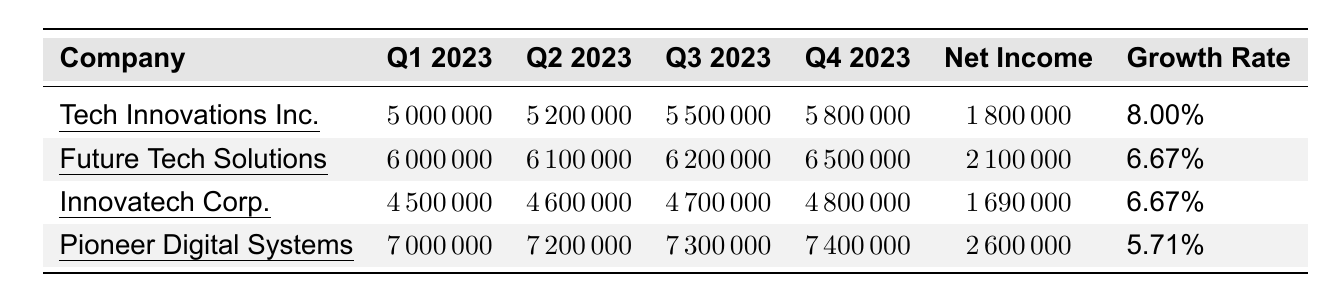What is the highest quarterly revenue reported in Q4 2023? From the table, the revenues for Q4 2023 are as follows: Tech Innovations Inc. is 5800000, Future Tech Solutions is 6500000, Innovatech Corp. is 4800000, and Pioneer Digital Systems is 7400000. The highest among these values is 7400000.
Answer: 7400000 Which company had the lowest net income? The net incomes listed are: Tech Innovations Inc. at 1800000, Future Tech Solutions at 2100000, Innovatech Corp. at 1690000, and Pioneer Digital Systems at 2600000. The lowest net income is from Innovatech Corp. at 1690000.
Answer: Innovatech Corp What is the average revenue for Q1 2023 across all companies? The revenues for Q1 2023 are: 5000000 (Tech Innovations Inc.), 6000000 (Future Tech Solutions), 4500000 (Innovatech Corp.), and 7000000 (Pioneer Digital Systems). Summing these gives 5000000 + 6000000 + 4500000 + 7000000 = 22500000. There are 4 companies, so the average is 22500000 / 4 = 5625000.
Answer: 5625000 Did any company show a growth rate of 8% or more? The growth rates listed are: Tech Innovations Inc. at 8%, Future Tech Solutions at 6.67%, Innovatech Corp. at 6.67%, and Pioneer Digital Systems at 5.71%. Since Tech Innovations Inc. is the only one at 8% and above, the answer is yes.
Answer: Yes What was the total increase in revenue from Q1 to Q4 for Pioneer Digital Systems? For Pioneer Digital Systems, the revenue in Q1 2023 was 7000000 and in Q4 2023 was 7400000. The increase is 7400000 - 7000000 = 400000.
Answer: 400000 Which company experienced the least growth relative to its net income? The growth rates relative to net income are for Tech Innovations Inc. at 8%, Future Tech Solutions at 6.67%, Innovatech Corp. at 6.67%, and Pioneer Digital Systems at 5.71%. The least growth rate is Pioneer Digital Systems at 5.71%.
Answer: Pioneer Digital Systems Is it true that Future Tech Solutions had a higher net income than Innovatech Corp.? The net income for Future Tech Solutions is 2100000 and for Innovatech Corp. is 1690000. Since 2100000 is greater than 1690000, the statement is true.
Answer: Yes What is the difference in net income between Tech Innovations Inc. and Pioneer Digital Systems? The net income for Tech Innovations Inc. is 1800000 and for Pioneer Digital Systems is 2600000. The difference is 2600000 - 1800000 = 800000.
Answer: 800000 Which company's revenue showed the most consistent growth each quarter? To assess consistency, we can compare the revenue growth for each company: Tech Innovations Inc. increased from 5000000 to 5800000 (+800000), Future Tech Solutions from 6000000 to 6500000 (+500000), Innovatech Corp. from 4500000 to 4800000 (+300000), and Pioneer Digital Systems from 7000000 to 7400000 (+400000). Tech Innovations Inc. showed the most stable and consistent growth across all quarters.
Answer: Tech Innovations Inc 